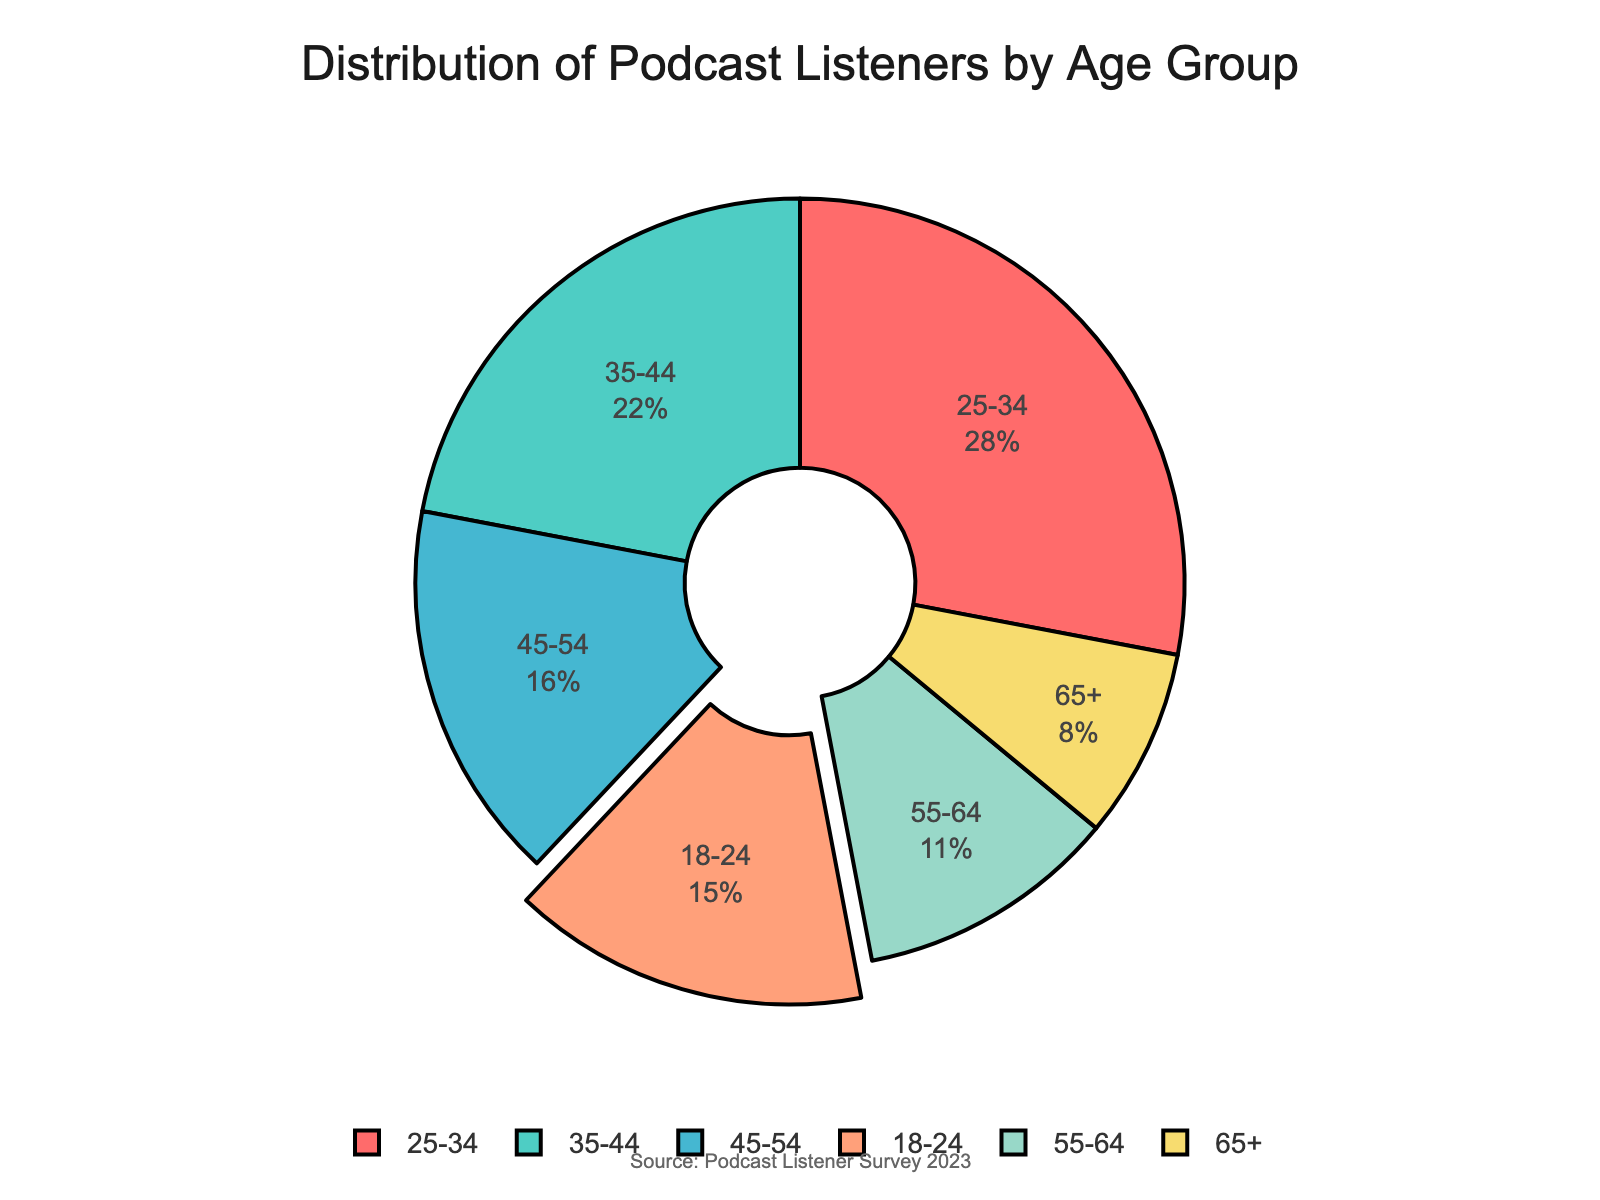What's the largest age group of podcast listeners according to the data? Identify the age group with the highest percentage in the pie chart. The segment labeled "25-34" has the value 28%, which is the highest among all age groups.
Answer: 25-34 How does the percentage of listeners aged 18-24 compare to those aged 45-54? Look at the segments labeled "18-24" and "45-54". The "18-24" segment represents 15%, and the "45-54" segment represents 16%, so the percentage for "45-54" is slightly higher.
Answer: 45-54 is higher Which age group has the smallest representation among podcast listeners? Determine the segment with the smallest percentage. The segment labeled "65+" is the smallest, at 8%.
Answer: 65+ What is the combined percentage of podcast listeners aged between 25 and 44? Sum the percentages of the "25-34" and "35-44" segments. The "25-34" segment is 28%, and the "35-44" segment is 22%. Thus, the combined percentage is 28% + 22% = 50%.
Answer: 50% What is the difference in percentage between the 55-64 age group and the 65+ age group? Subtract the percentage of the "65+" segment from the "55-64" segment. The "55-64" segment is 11%, and the "65+" segment is 8%, so the difference is 11% - 8% = 3%.
Answer: 3% What percentage of listeners are aged 24 years or younger? Look at the percentage for the "18-24" segment. The "18-24" segment has a percentage of 15%.
Answer: 15% Which two age groups have the combined highest percentage of podcast listeners? Identify the two segments with the highest individual percentages and sum them. The "25-34" segment has 28% and the "35-44" segment has 22%, giving a total of 28% + 22% = 50%, which is the highest combined value.
Answer: 25-34 and 35-44 What is the average percentage of podcast listeners for the age groups 35-44, 45-54, and 55-64? Calculate the average by summing the percentages for these age groups and dividing by the number of groups. The percentages are 22% (35-44), 16% (45-54), and 11% (55-64). Sum is 22% + 16% + 11% = 49%. Divide by 3 to get the average: 49% / 3 ≈ 16.33%.
Answer: 16.33% Which age group segment is depicted in red on the chart? Identify the segment with red color marked visually. The red segment represents the "18-24" age group.
Answer: 18-24 